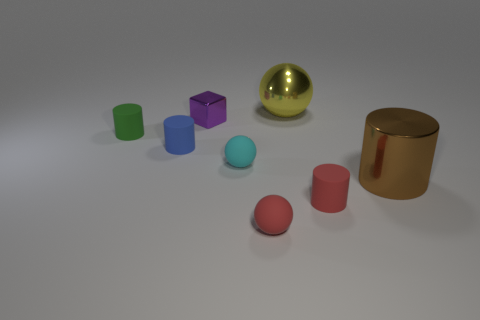Is there a yellow object that has the same size as the red ball?
Offer a terse response. No. Is the number of large gray rubber balls less than the number of big metallic spheres?
Your answer should be very brief. Yes. How many spheres are either yellow rubber objects or yellow things?
Your answer should be compact. 1. What size is the sphere that is behind the small red cylinder and right of the cyan ball?
Your answer should be very brief. Large. Are there fewer cyan rubber balls in front of the red matte cylinder than purple cubes?
Your answer should be very brief. Yes. Is the red cylinder made of the same material as the tiny green cylinder?
Offer a terse response. Yes. What number of things are either large yellow shiny objects or blue objects?
Offer a very short reply. 2. What number of big gray blocks have the same material as the small green cylinder?
Your response must be concise. 0. There is a brown thing that is the same shape as the tiny green rubber object; what size is it?
Provide a succinct answer. Large. There is a brown thing; are there any cylinders behind it?
Ensure brevity in your answer.  Yes. 